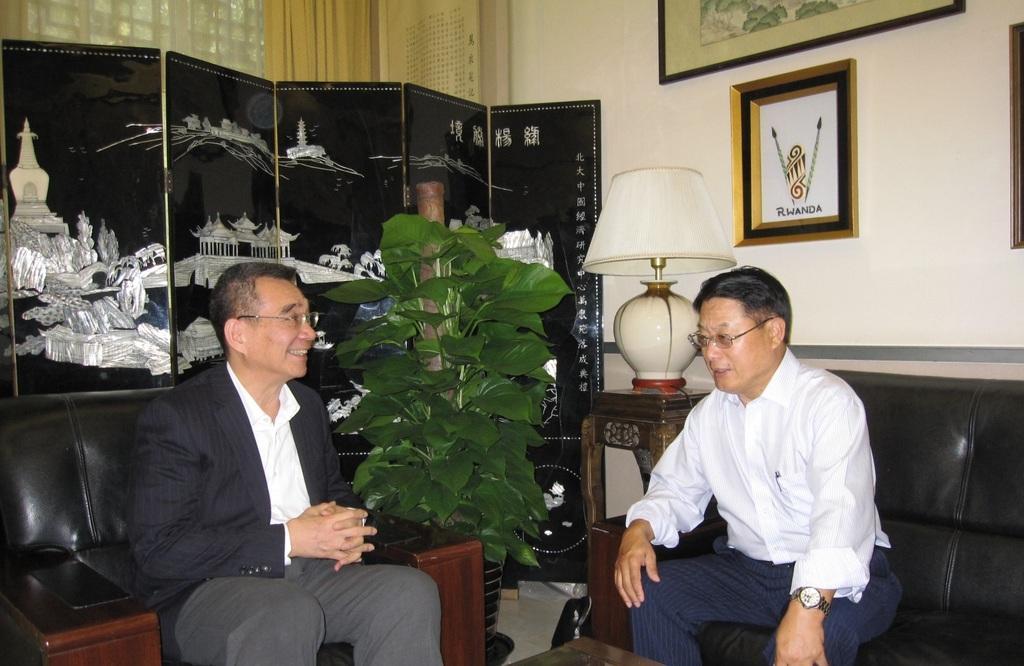Could you give a brief overview of what you see in this image? There are two people sitting on the couch and talking. This is the house plant. Here is the lamp placed on the table. These are the photo frames attached to the wall. This looks like a door with a painting on it. At background I can see a curtain hanging. 